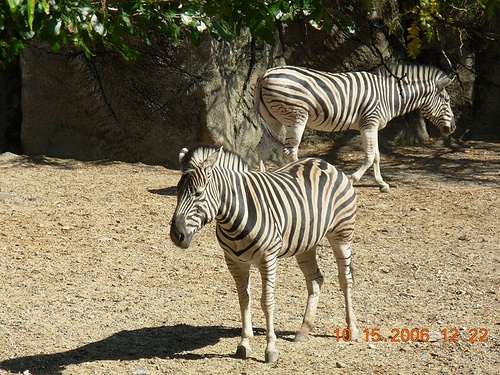Describe the objects in this image and their specific colors. I can see zebra in black, beige, gray, and tan tones and zebra in black, gray, and beige tones in this image. 